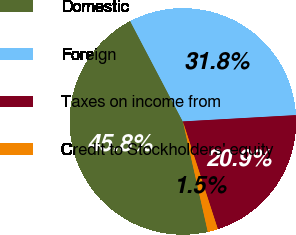<chart> <loc_0><loc_0><loc_500><loc_500><pie_chart><fcel>Domestic<fcel>Foreign<fcel>Taxes on income from<fcel>Credit to Stockholders' equity<nl><fcel>45.85%<fcel>31.81%<fcel>20.89%<fcel>1.46%<nl></chart> 